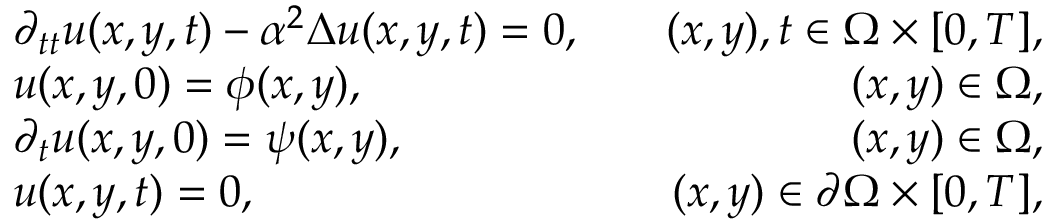Convert formula to latex. <formula><loc_0><loc_0><loc_500><loc_500>\begin{array} { r l r } & { \partial _ { t t } u ( x , y , t ) - \alpha ^ { 2 } \Delta u ( x , y , t ) = 0 , } & { \quad ( x , y ) , t \in \Omega \times [ 0 , T ] , } \\ & { u ( x , y , 0 ) = \phi ( x , y ) , } & { \quad ( x , y ) \in \Omega , } \\ & { \partial _ { t } u ( x , y , 0 ) = \psi ( x , y ) , } & { \quad ( x , y ) \in \Omega , } \\ & { u ( x , y , t ) = 0 , } & { \quad ( x , y ) \in \partial \Omega \times [ 0 , T ] , } \end{array}</formula> 